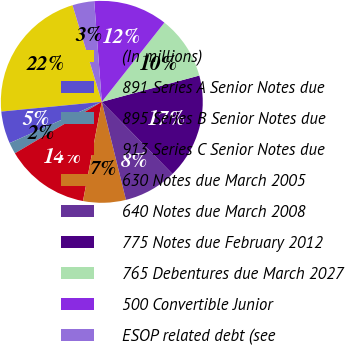Convert chart to OTSL. <chart><loc_0><loc_0><loc_500><loc_500><pie_chart><fcel>(In millions)<fcel>891 Series A Senior Notes due<fcel>895 Series B Senior Notes due<fcel>913 Series C Senior Notes due<fcel>630 Notes due March 2005<fcel>640 Notes due March 2008<fcel>775 Notes due February 2012<fcel>765 Debentures due March 2027<fcel>500 Convertible Junior<fcel>ESOP related debt (see<nl><fcel>21.86%<fcel>5.16%<fcel>1.82%<fcel>13.51%<fcel>6.83%<fcel>8.5%<fcel>16.85%<fcel>10.17%<fcel>11.84%<fcel>3.49%<nl></chart> 